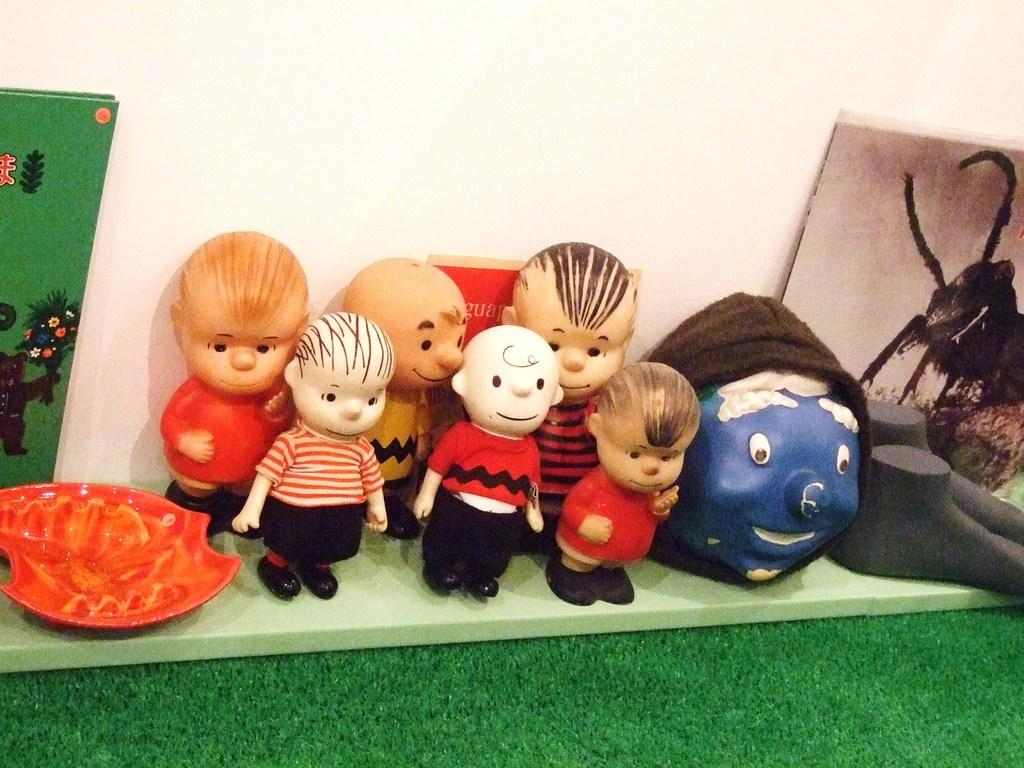What objects are present in the image? There are toys in the image. What colors can be seen on the toys? The toys are in red and black colors. What can be seen in the background of the image? There is a wall in the background of the image. What type of alarm can be heard in the image? There is no alarm present in the image. 